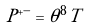<formula> <loc_0><loc_0><loc_500><loc_500>P ^ { + - } = \theta ^ { 8 } T</formula> 